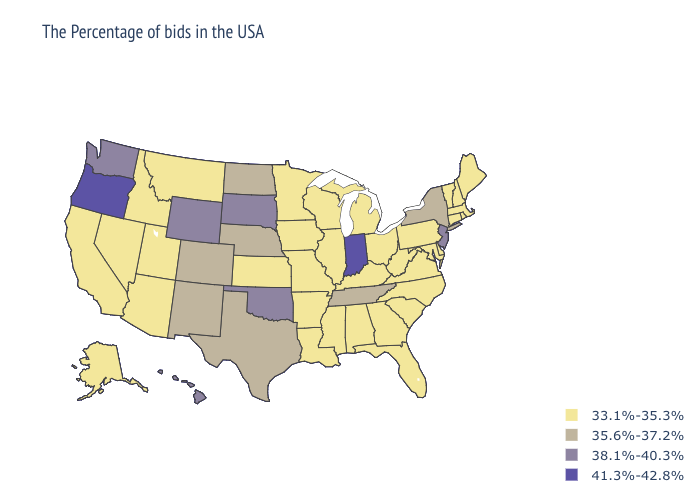What is the value of Colorado?
Quick response, please. 35.6%-37.2%. Does Oregon have the highest value in the USA?
Concise answer only. Yes. What is the highest value in the Northeast ?
Answer briefly. 38.1%-40.3%. Among the states that border Maryland , which have the highest value?
Be succinct. Delaware, Pennsylvania, Virginia, West Virginia. Among the states that border Nebraska , which have the highest value?
Concise answer only. South Dakota, Wyoming. What is the lowest value in states that border Maine?
Give a very brief answer. 33.1%-35.3%. Name the states that have a value in the range 38.1%-40.3%?
Give a very brief answer. New Jersey, Oklahoma, South Dakota, Wyoming, Washington, Hawaii. Is the legend a continuous bar?
Write a very short answer. No. Among the states that border Arizona , does New Mexico have the highest value?
Short answer required. Yes. Does the first symbol in the legend represent the smallest category?
Write a very short answer. Yes. Name the states that have a value in the range 38.1%-40.3%?
Answer briefly. New Jersey, Oklahoma, South Dakota, Wyoming, Washington, Hawaii. What is the value of Rhode Island?
Give a very brief answer. 33.1%-35.3%. Which states hav the highest value in the Northeast?
Be succinct. New Jersey. Does Tennessee have the lowest value in the USA?
Give a very brief answer. No. Which states have the highest value in the USA?
Keep it brief. Indiana, Oregon. 